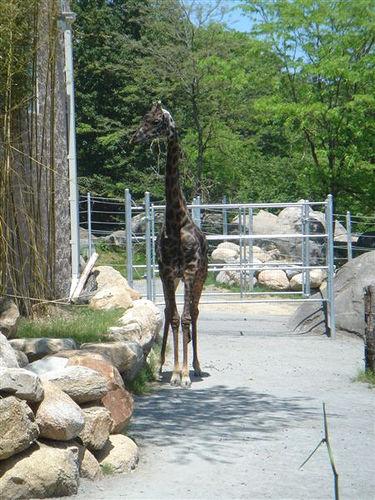Is this a wild animal?
Short answer required. No. Is it a sunny day?
Quick response, please. Yes. Is this a garden?
Quick response, please. No. How many giraffes are there?
Be succinct. 1. Where is the animal?
Concise answer only. Giraffe. 